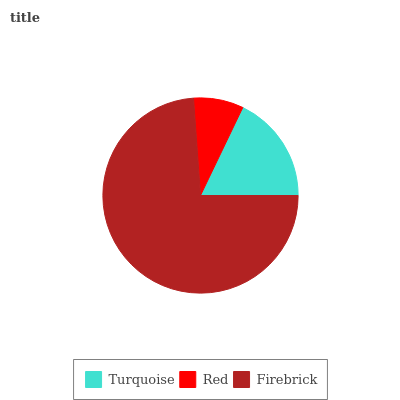Is Red the minimum?
Answer yes or no. Yes. Is Firebrick the maximum?
Answer yes or no. Yes. Is Firebrick the minimum?
Answer yes or no. No. Is Red the maximum?
Answer yes or no. No. Is Firebrick greater than Red?
Answer yes or no. Yes. Is Red less than Firebrick?
Answer yes or no. Yes. Is Red greater than Firebrick?
Answer yes or no. No. Is Firebrick less than Red?
Answer yes or no. No. Is Turquoise the high median?
Answer yes or no. Yes. Is Turquoise the low median?
Answer yes or no. Yes. Is Firebrick the high median?
Answer yes or no. No. Is Firebrick the low median?
Answer yes or no. No. 